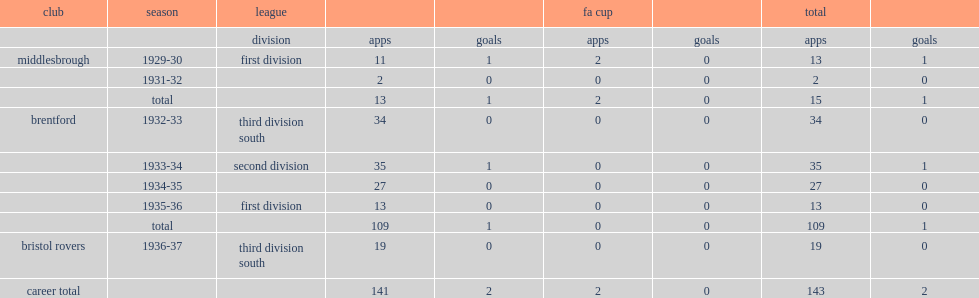What was the number of appearances made by herbert watson in the first division during the 1935-36 season in brentford. 13.0. 